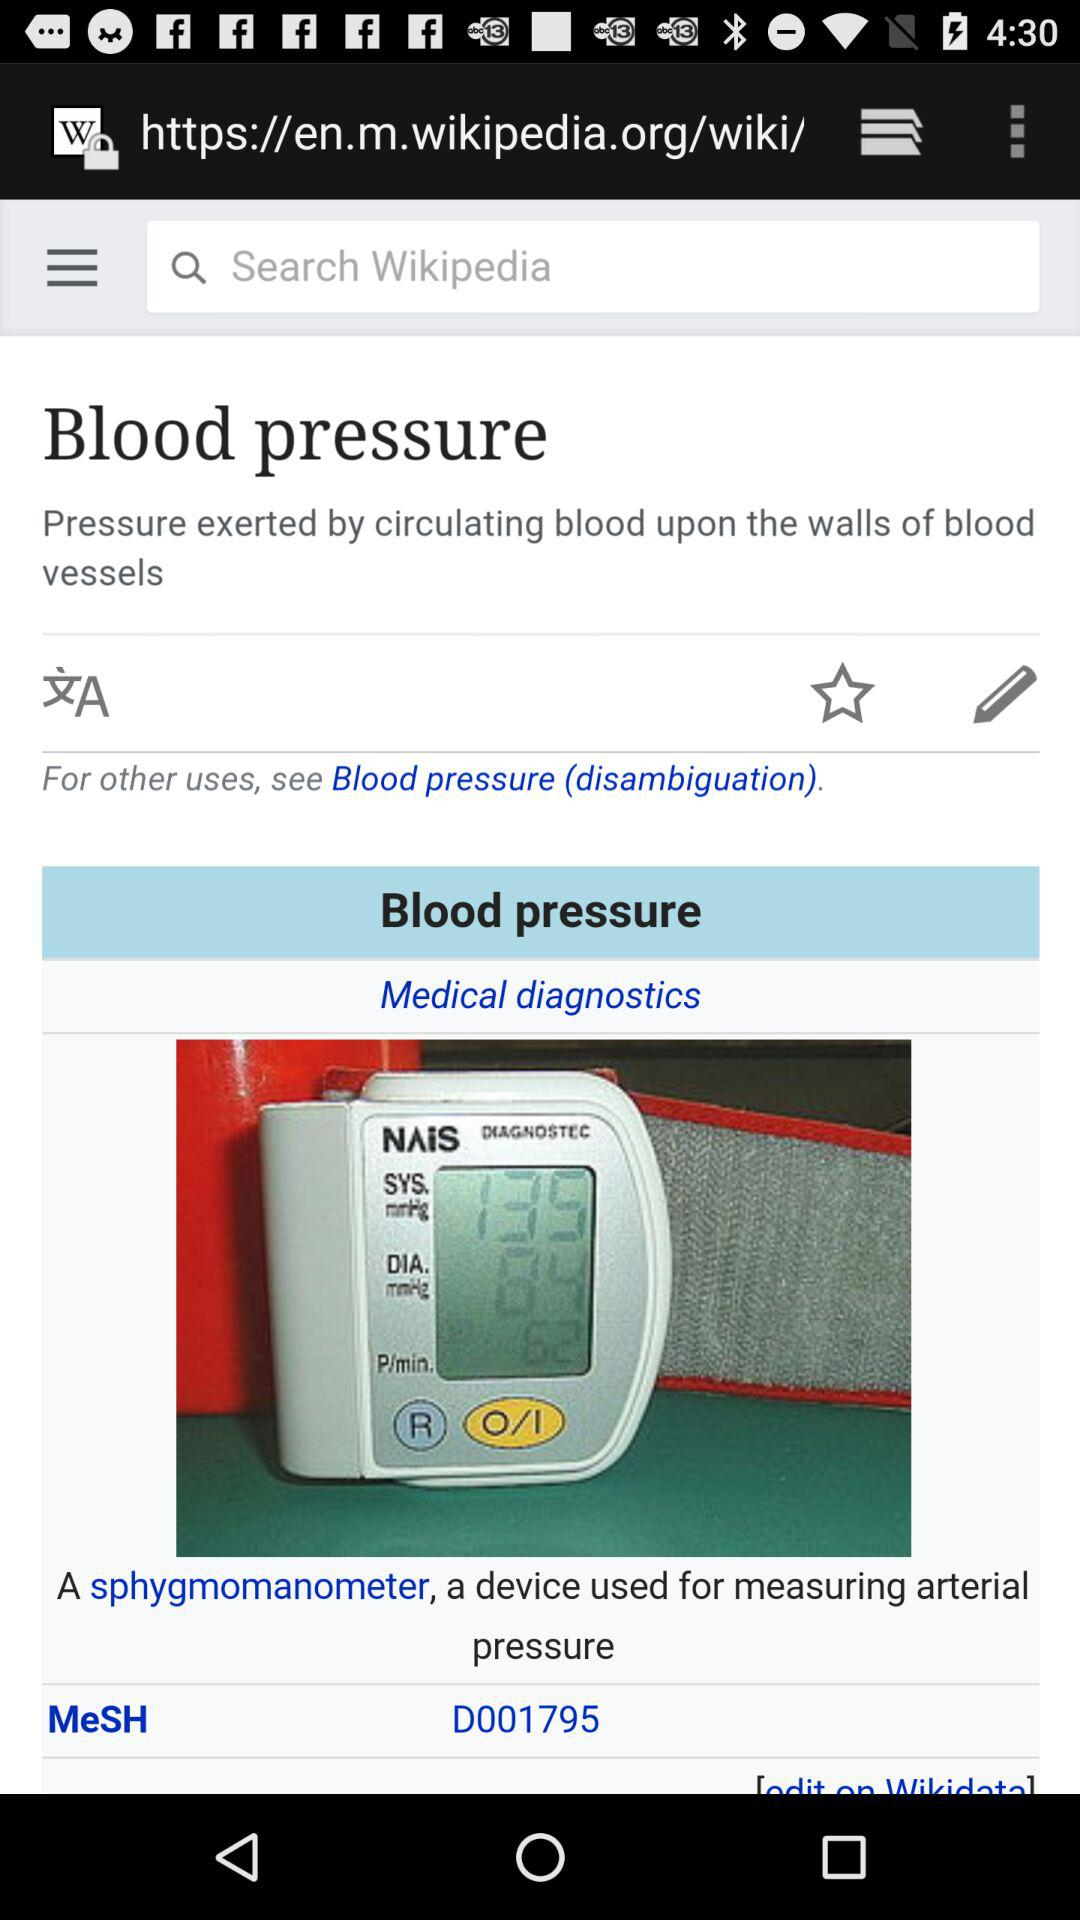What is the blood pressure's MeSH number? Blood pressure's MeSH number is D001795. 